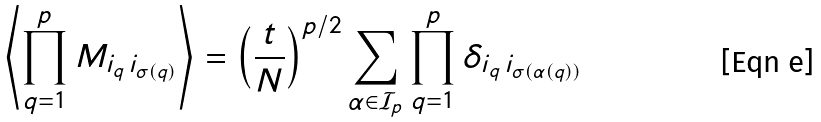Convert formula to latex. <formula><loc_0><loc_0><loc_500><loc_500>\left \langle \prod _ { q = 1 } ^ { p } M _ { i _ { q } \, i _ { \sigma ( q ) } } \right \rangle = \left ( \frac { t } { N } \right ) ^ { p / 2 } \sum _ { \alpha \in \mathcal { I } _ { p } } \prod _ { q = 1 } ^ { p } \delta _ { i _ { q } \, i _ { \sigma ( \alpha ( q ) ) } }</formula> 